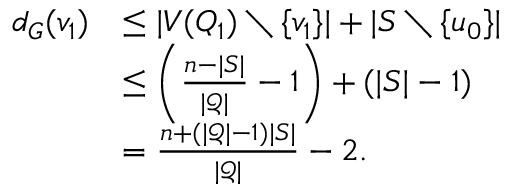Convert formula to latex. <formula><loc_0><loc_0><loc_500><loc_500>\begin{array} { r l } { d _ { G } ( v _ { 1 } ) } & { \leq | V ( Q _ { 1 } ) \ \{ v _ { 1 } \} | + | S \ \{ u _ { 0 } \} | } \\ & { \leq \left ( \frac { n - | S | } { | { \mathcal { Q } } | } - 1 \right ) + ( | S | - 1 ) } \\ & { = \frac { n + ( | { \mathcal { Q } } | - 1 ) | S | } { | { \mathcal { Q } } | } - 2 . } \end{array}</formula> 